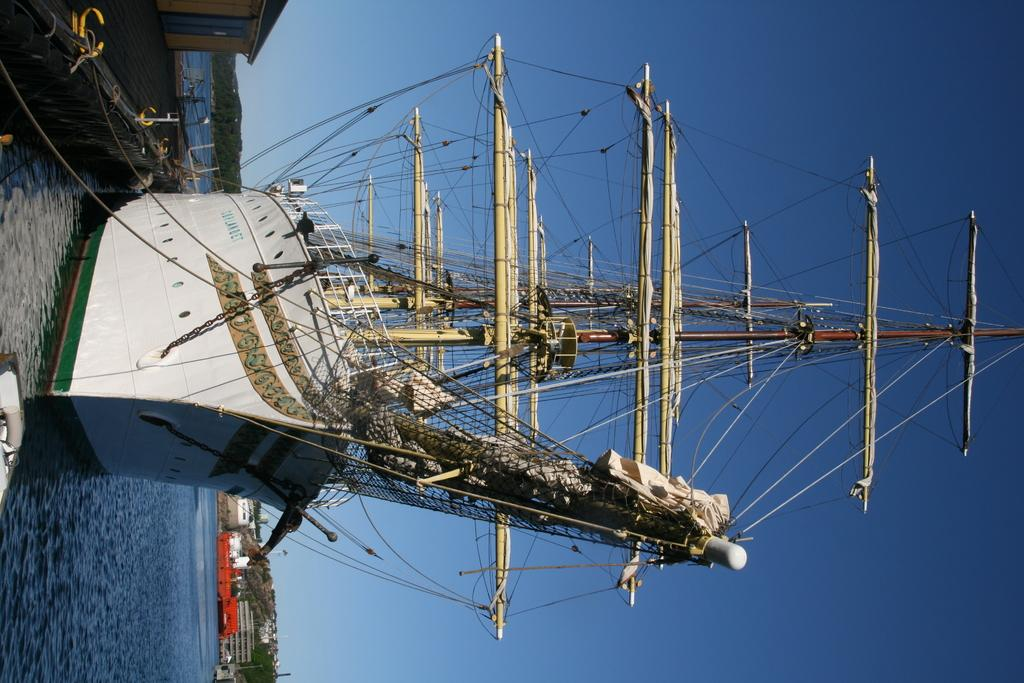What is the main subject of the image? The main subject of the image is a ship. What other objects or structures can be seen in the image? There are poles, wires, water, a floor, a house, mountains, and buildings visible in the image. What is the background of the image? The background of the image includes mountains, buildings, and the sky. What type of environment is depicted in the image? The image depicts a coastal or harbor environment, with a ship, water, and mountains. Can you tell me how many babies are on the ship in the image? There is no baby present on the ship in the image. What type of attack is being carried out on the ship in the image? There is no attack depicted in the image; it shows a ship in a coastal or harbor environment. 